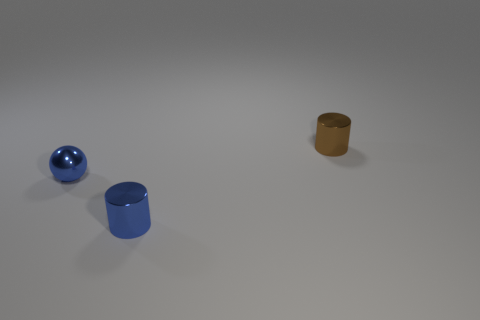Add 1 brown metal things. How many objects exist? 4 Subtract all blue cylinders. How many cylinders are left? 1 Add 1 small yellow rubber objects. How many small yellow rubber objects exist? 1 Subtract 1 blue cylinders. How many objects are left? 2 Subtract all balls. How many objects are left? 2 Subtract all yellow cylinders. Subtract all purple cubes. How many cylinders are left? 2 Subtract all yellow spheres. How many blue cylinders are left? 1 Subtract all tiny red matte cylinders. Subtract all small brown cylinders. How many objects are left? 2 Add 3 brown cylinders. How many brown cylinders are left? 4 